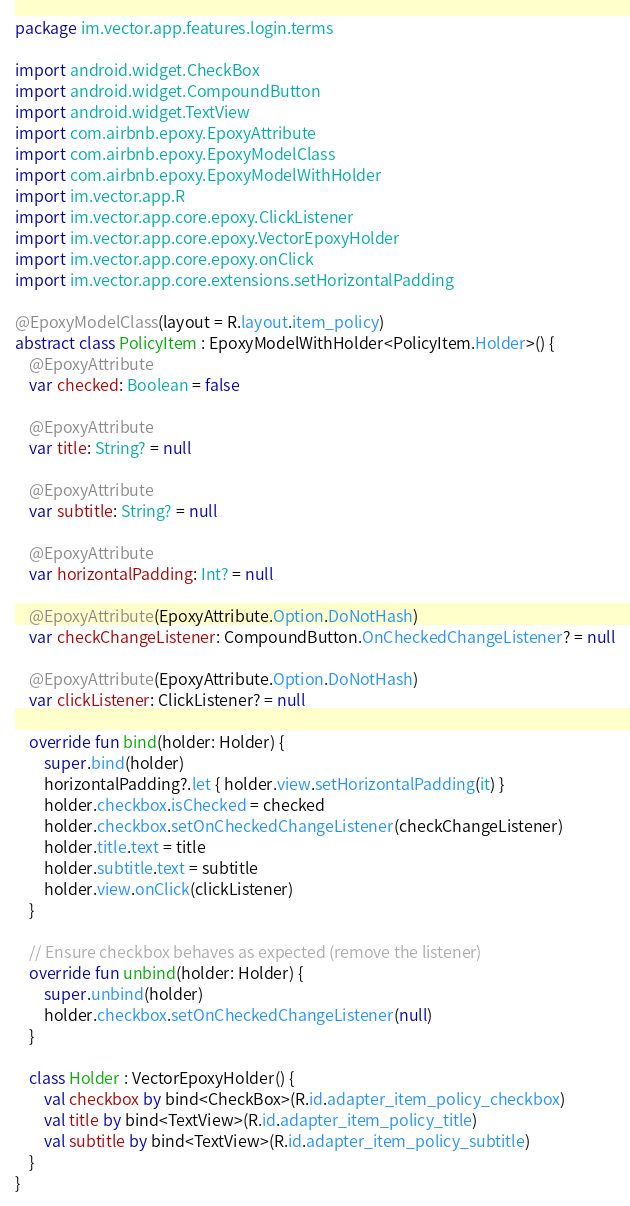Convert code to text. <code><loc_0><loc_0><loc_500><loc_500><_Kotlin_>
package im.vector.app.features.login.terms

import android.widget.CheckBox
import android.widget.CompoundButton
import android.widget.TextView
import com.airbnb.epoxy.EpoxyAttribute
import com.airbnb.epoxy.EpoxyModelClass
import com.airbnb.epoxy.EpoxyModelWithHolder
import im.vector.app.R
import im.vector.app.core.epoxy.ClickListener
import im.vector.app.core.epoxy.VectorEpoxyHolder
import im.vector.app.core.epoxy.onClick
import im.vector.app.core.extensions.setHorizontalPadding

@EpoxyModelClass(layout = R.layout.item_policy)
abstract class PolicyItem : EpoxyModelWithHolder<PolicyItem.Holder>() {
    @EpoxyAttribute
    var checked: Boolean = false

    @EpoxyAttribute
    var title: String? = null

    @EpoxyAttribute
    var subtitle: String? = null

    @EpoxyAttribute
    var horizontalPadding: Int? = null

    @EpoxyAttribute(EpoxyAttribute.Option.DoNotHash)
    var checkChangeListener: CompoundButton.OnCheckedChangeListener? = null

    @EpoxyAttribute(EpoxyAttribute.Option.DoNotHash)
    var clickListener: ClickListener? = null

    override fun bind(holder: Holder) {
        super.bind(holder)
        horizontalPadding?.let { holder.view.setHorizontalPadding(it) }
        holder.checkbox.isChecked = checked
        holder.checkbox.setOnCheckedChangeListener(checkChangeListener)
        holder.title.text = title
        holder.subtitle.text = subtitle
        holder.view.onClick(clickListener)
    }

    // Ensure checkbox behaves as expected (remove the listener)
    override fun unbind(holder: Holder) {
        super.unbind(holder)
        holder.checkbox.setOnCheckedChangeListener(null)
    }

    class Holder : VectorEpoxyHolder() {
        val checkbox by bind<CheckBox>(R.id.adapter_item_policy_checkbox)
        val title by bind<TextView>(R.id.adapter_item_policy_title)
        val subtitle by bind<TextView>(R.id.adapter_item_policy_subtitle)
    }
}
</code> 